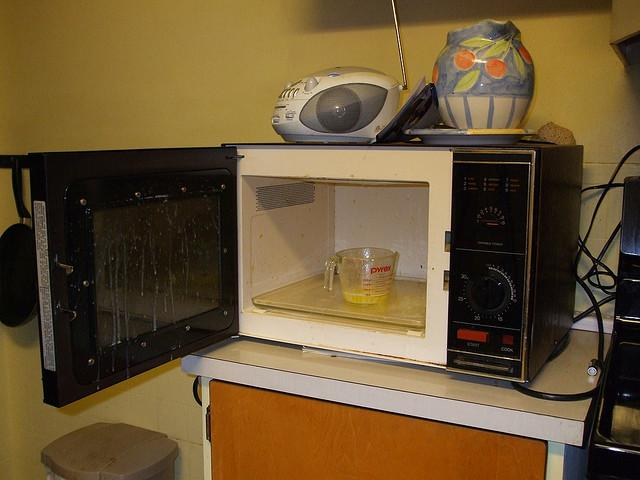How is the measuring cup being heated?

Choices:
A) grill
B) microwave
C) oven
D) stove microwave 